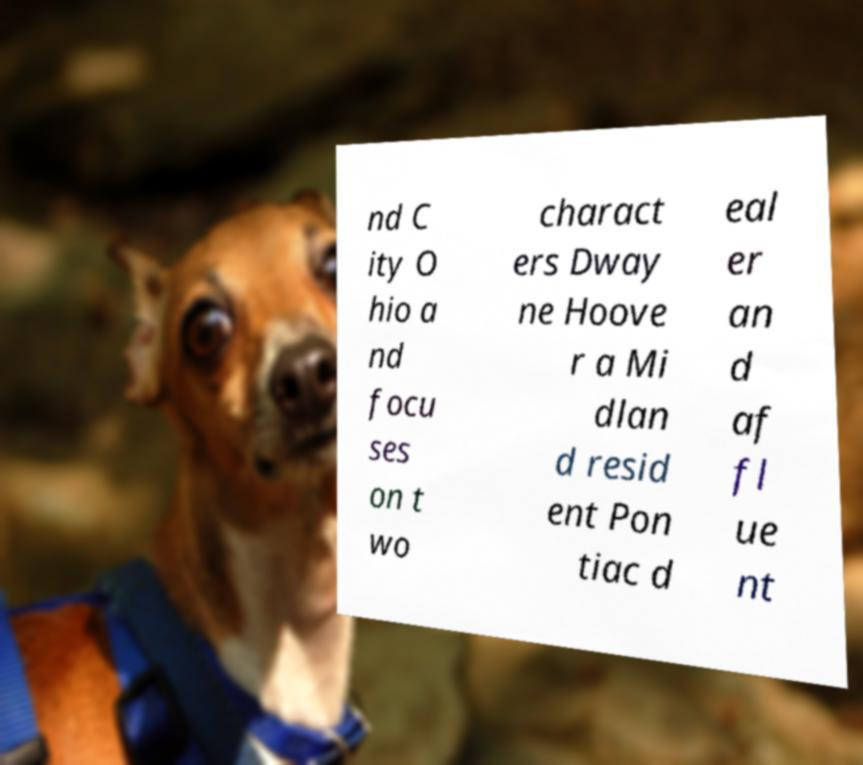I need the written content from this picture converted into text. Can you do that? nd C ity O hio a nd focu ses on t wo charact ers Dway ne Hoove r a Mi dlan d resid ent Pon tiac d eal er an d af fl ue nt 